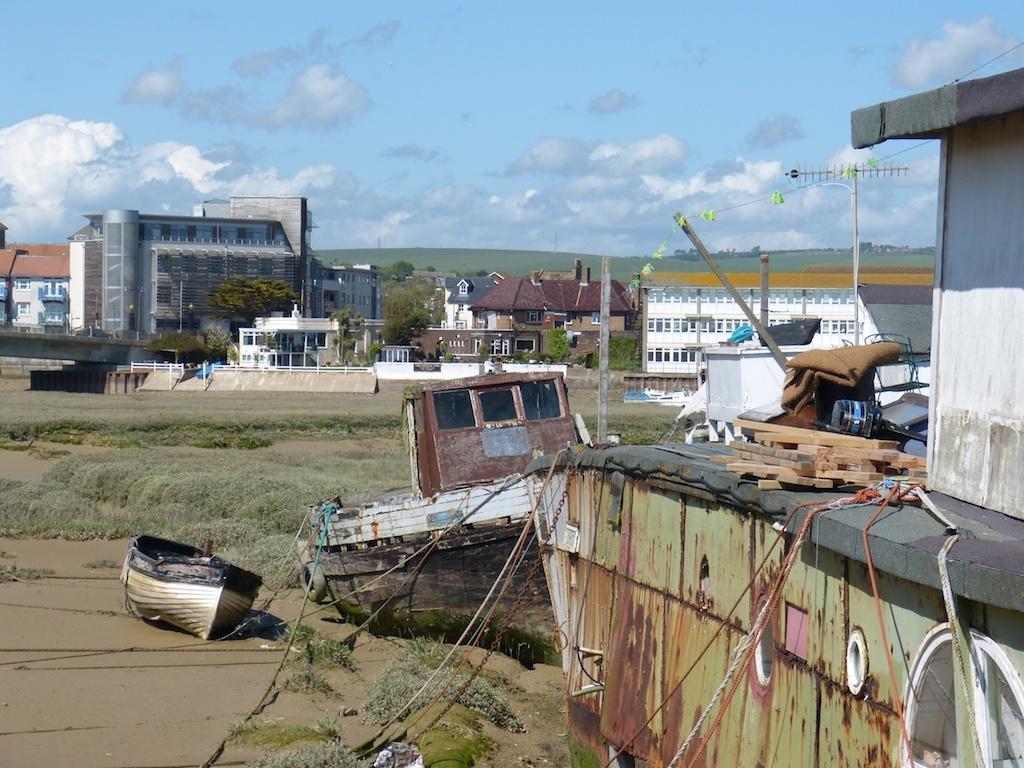How would you summarize this image in a sentence or two? In this image on the right side there is house, clothes, boards, ropes, chains, antenna and some other objects. And on the left side there is a boat, sand and some grass and in the background there are some buildings, trees, poles, mountains, and at the top there is sky. 